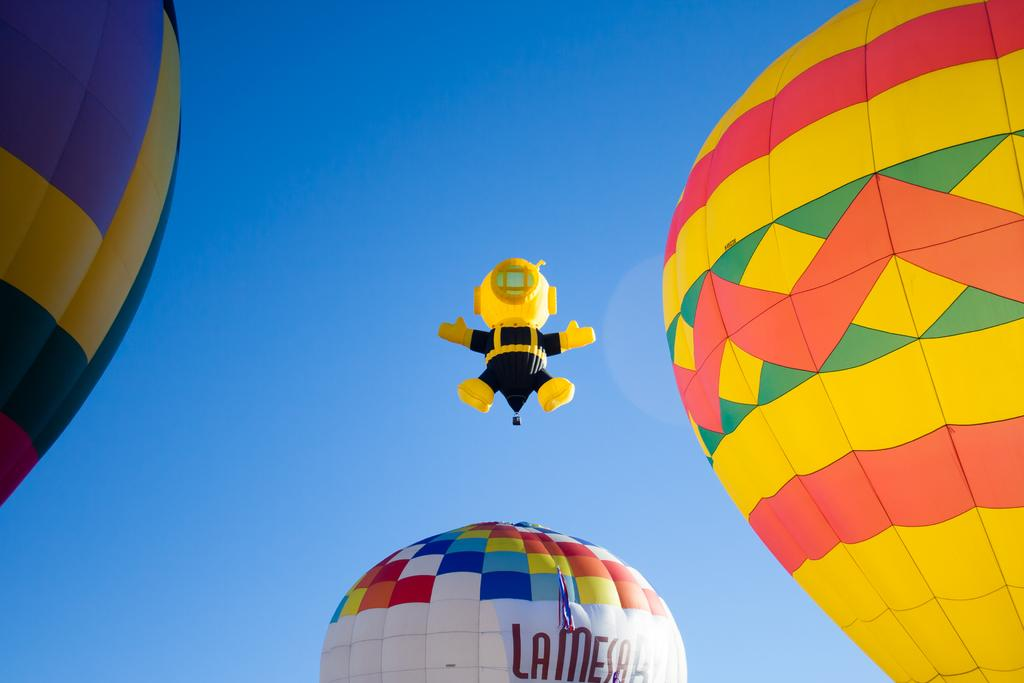<image>
Render a clear and concise summary of the photo. Hot air ballons including a La Mesa ballon taking off 